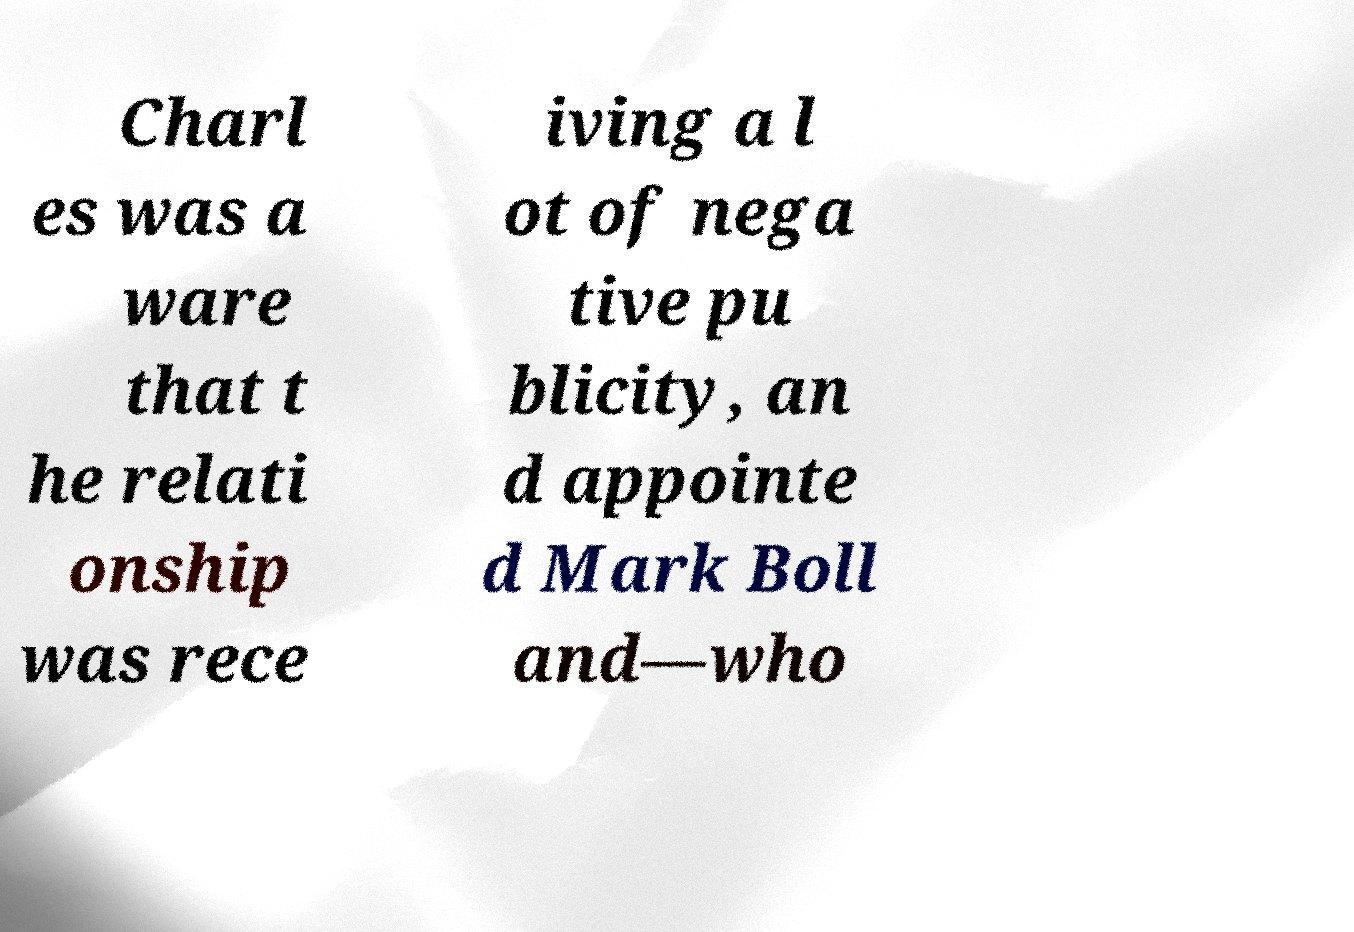Please identify and transcribe the text found in this image. Charl es was a ware that t he relati onship was rece iving a l ot of nega tive pu blicity, an d appointe d Mark Boll and—who 